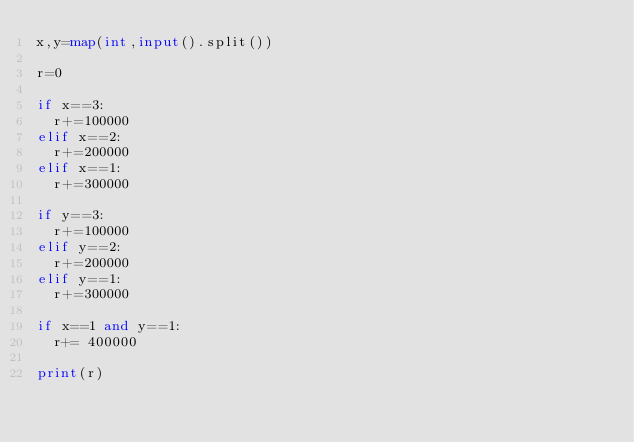Convert code to text. <code><loc_0><loc_0><loc_500><loc_500><_Python_>x,y=map(int,input().split())

r=0

if x==3:
  r+=100000
elif x==2:
  r+=200000
elif x==1:
  r+=300000
  
if y==3:
  r+=100000
elif y==2:
  r+=200000
elif y==1:
  r+=300000
  
if x==1 and y==1:
  r+= 400000

print(r)
 
</code> 